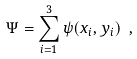<formula> <loc_0><loc_0><loc_500><loc_500>\Psi = \sum _ { i = 1 } ^ { 3 } \psi ( { x } _ { i } , { y } _ { i } ) \ ,</formula> 